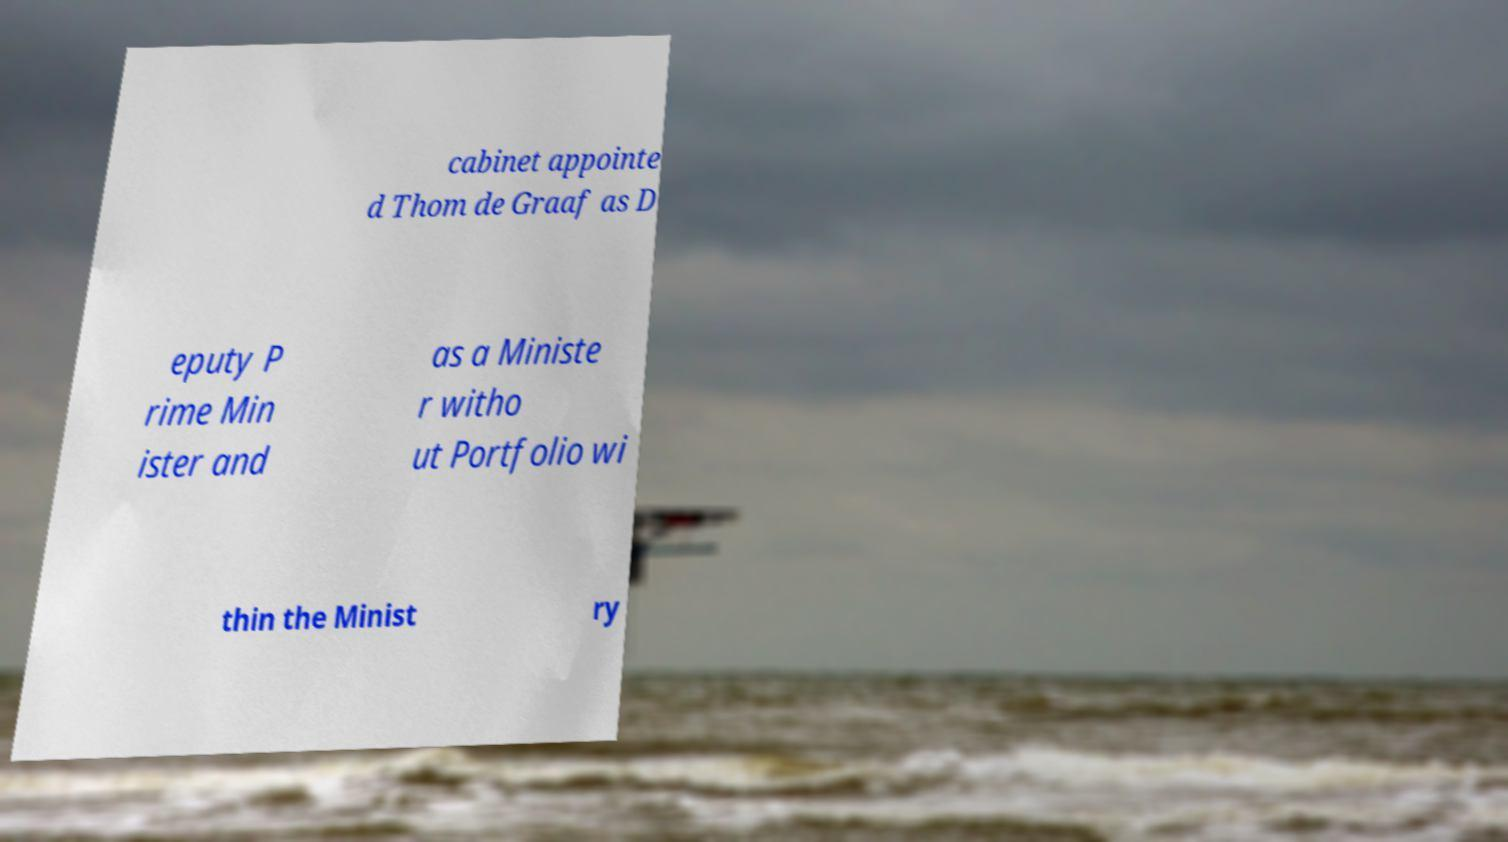What messages or text are displayed in this image? I need them in a readable, typed format. cabinet appointe d Thom de Graaf as D eputy P rime Min ister and as a Ministe r witho ut Portfolio wi thin the Minist ry 